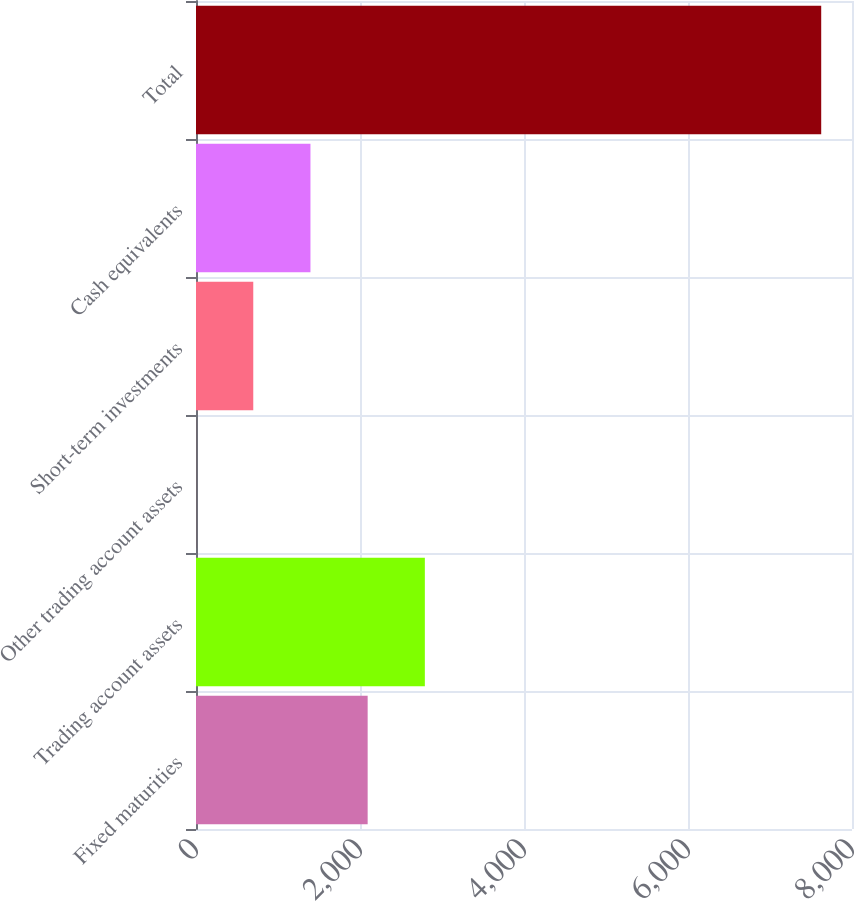<chart> <loc_0><loc_0><loc_500><loc_500><bar_chart><fcel>Fixed maturities<fcel>Trading account assets<fcel>Other trading account assets<fcel>Short-term investments<fcel>Cash equivalents<fcel>Total<nl><fcel>2093.37<fcel>2790.89<fcel>0.81<fcel>698.33<fcel>1395.85<fcel>7624.52<nl></chart> 